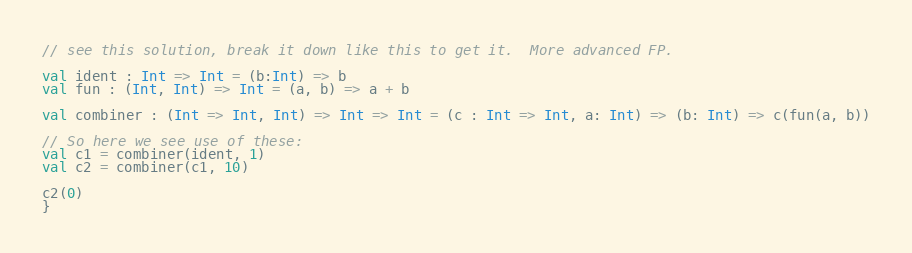<code> <loc_0><loc_0><loc_500><loc_500><_Scala_>// see this solution, break it down like this to get it.  More advanced FP.

val ident : Int => Int = (b:Int) => b
val fun : (Int, Int) => Int = (a, b) => a + b

val combiner : (Int => Int, Int) => Int => Int = (c : Int => Int, a: Int) => (b: Int) => c(fun(a, b))

// So here we see use of these:
val c1 = combiner(ident, 1)
val c2 = combiner(c1, 10)

c2(0)
}
</code> 